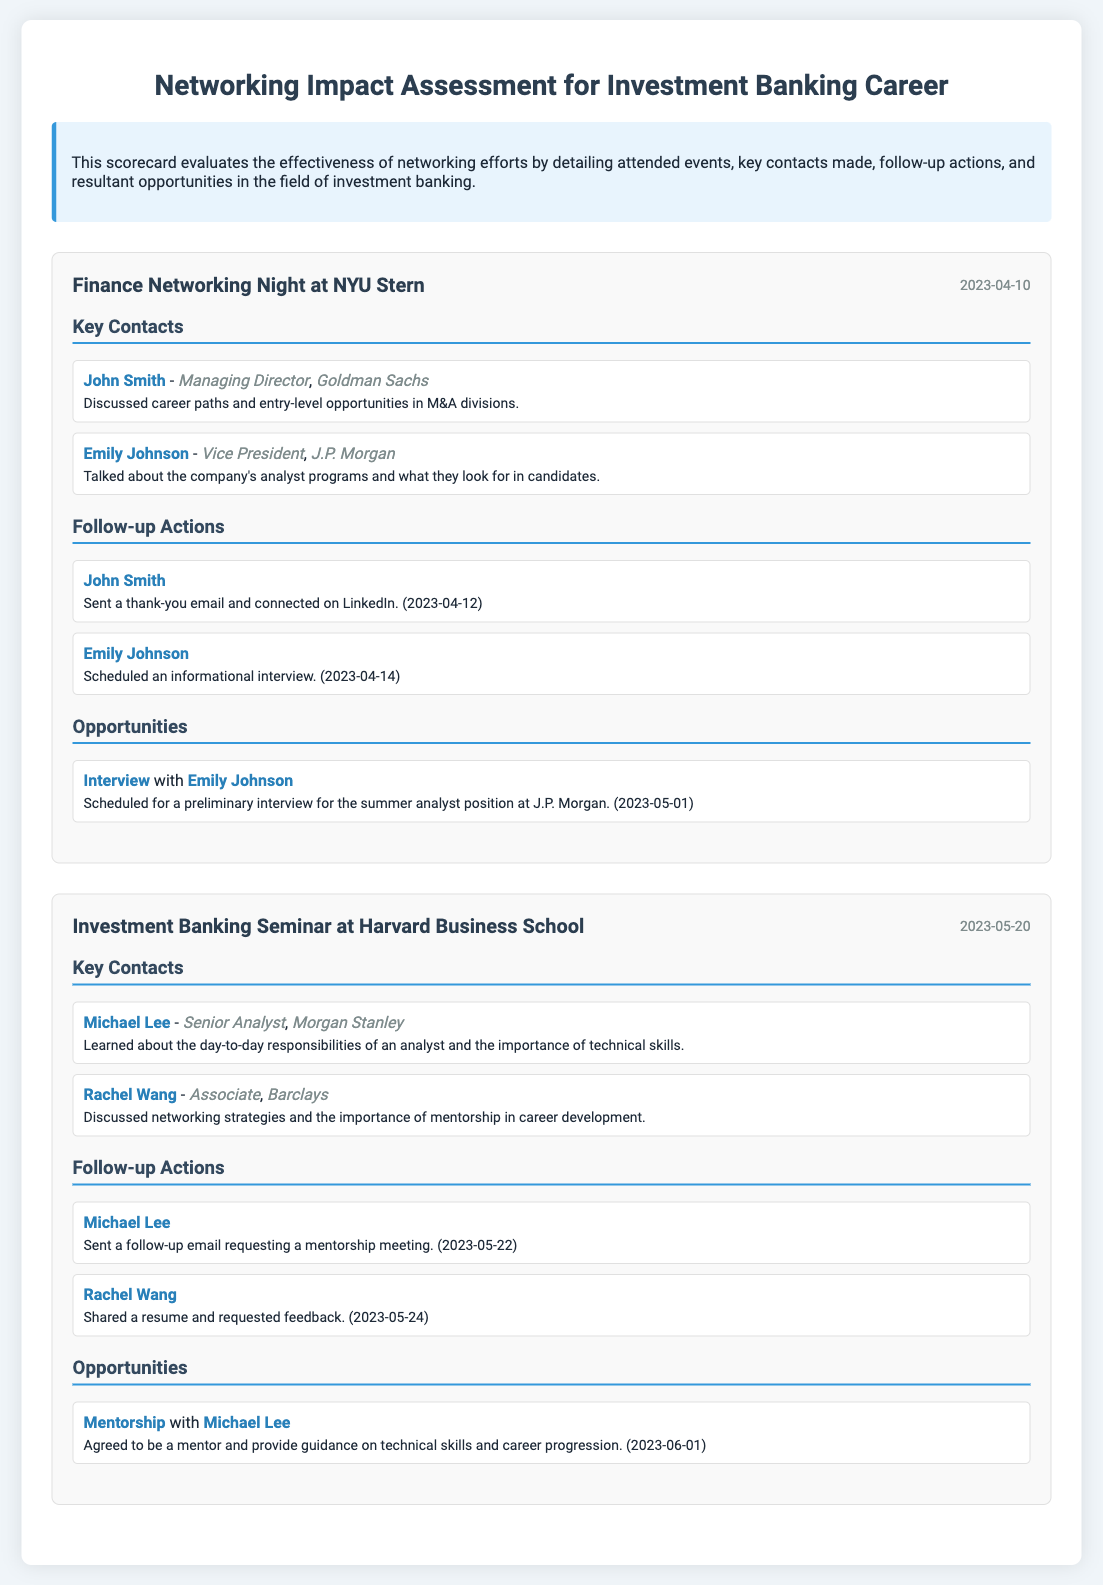What event was attended on April 10, 2023? The event attended on April 10, 2023, was "Finance Networking Night at NYU Stern."
Answer: Finance Networking Night at NYU Stern Who is the Managing Director at Goldman Sachs? The document states that John Smith is the Managing Director at Goldman Sachs.
Answer: John Smith What type of opportunity was scheduled with Emily Johnson? The document mentions an "Interview" opportunity with Emily Johnson.
Answer: Interview How many follow-up actions were taken after the Investment Banking Seminar? There were two follow-up actions listed after the Investment Banking Seminar.
Answer: 2 What was the date of the mentorship agreement with Michael Lee? The mentorship agreement with Michael Lee was made on June 1, 2023.
Answer: June 1, 2023 Which company does Rachel Wang work for? Rachel Wang is affiliated with Barclays.
Answer: Barclays What was discussed with Michael Lee during the networking event? The discussion with Michael Lee centered around the day-to-day responsibilities of an analyst.
Answer: Responsibilities of an analyst How many key contacts were made at the Finance Networking Night? Two key contacts were made at the Finance Networking Night.
Answer: 2 What action was taken for Rachel Wang on May 24, 2023? The action taken for Rachel Wang was sharing a resume and requesting feedback.
Answer: Shared a resume and requested feedback 